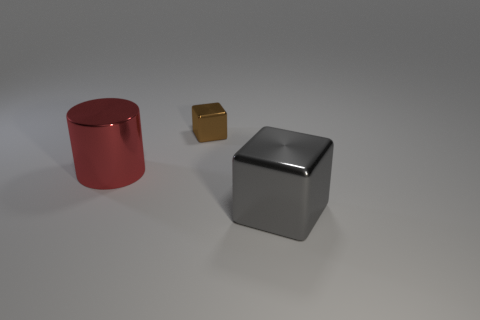There is a large object that is to the right of the red shiny cylinder; is it the same color as the thing that is behind the metal cylinder?
Offer a very short reply. No. What number of other things are made of the same material as the red cylinder?
Your answer should be very brief. 2. Are any small brown balls visible?
Provide a short and direct response. No. Is the material of the large object that is in front of the big red shiny thing the same as the cylinder?
Keep it short and to the point. Yes. What is the material of the other thing that is the same shape as the large gray metallic thing?
Ensure brevity in your answer.  Metal. Are there fewer small purple metallic cylinders than metallic blocks?
Make the answer very short. Yes. Is the color of the large thing left of the small brown metal thing the same as the small block?
Your response must be concise. No. What is the color of the big block that is made of the same material as the big cylinder?
Offer a terse response. Gray. Is the gray metallic thing the same size as the brown metal block?
Offer a very short reply. No. What is the tiny cube made of?
Ensure brevity in your answer.  Metal. 